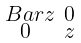Convert formula to latex. <formula><loc_0><loc_0><loc_500><loc_500>\begin{smallmatrix} \ B a r { z } & 0 \\ 0 & z \end{smallmatrix}</formula> 